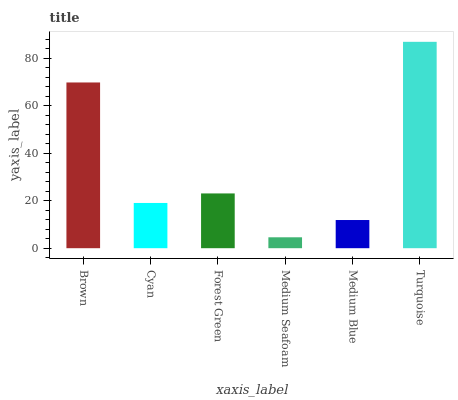Is Cyan the minimum?
Answer yes or no. No. Is Cyan the maximum?
Answer yes or no. No. Is Brown greater than Cyan?
Answer yes or no. Yes. Is Cyan less than Brown?
Answer yes or no. Yes. Is Cyan greater than Brown?
Answer yes or no. No. Is Brown less than Cyan?
Answer yes or no. No. Is Forest Green the high median?
Answer yes or no. Yes. Is Cyan the low median?
Answer yes or no. Yes. Is Cyan the high median?
Answer yes or no. No. Is Brown the low median?
Answer yes or no. No. 